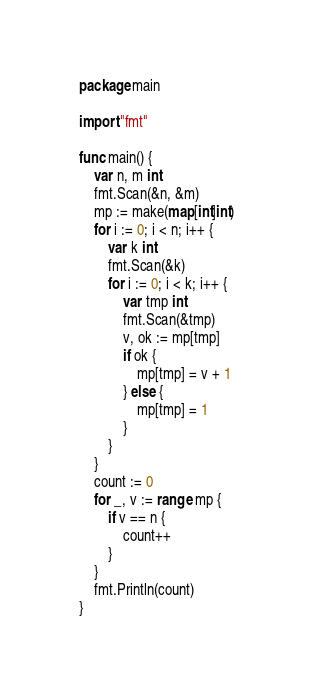Convert code to text. <code><loc_0><loc_0><loc_500><loc_500><_Go_>package main

import "fmt"

func main() {
	var n, m int
	fmt.Scan(&n, &m)
	mp := make(map[int]int)
	for i := 0; i < n; i++ {
		var k int
		fmt.Scan(&k)
		for i := 0; i < k; i++ {
			var tmp int
			fmt.Scan(&tmp)
			v, ok := mp[tmp]
			if ok {
				mp[tmp] = v + 1
			} else {
				mp[tmp] = 1
			}
		}
	}
	count := 0
	for _, v := range mp {
		if v == n {
			count++
		}
	}
	fmt.Println(count)
}</code> 